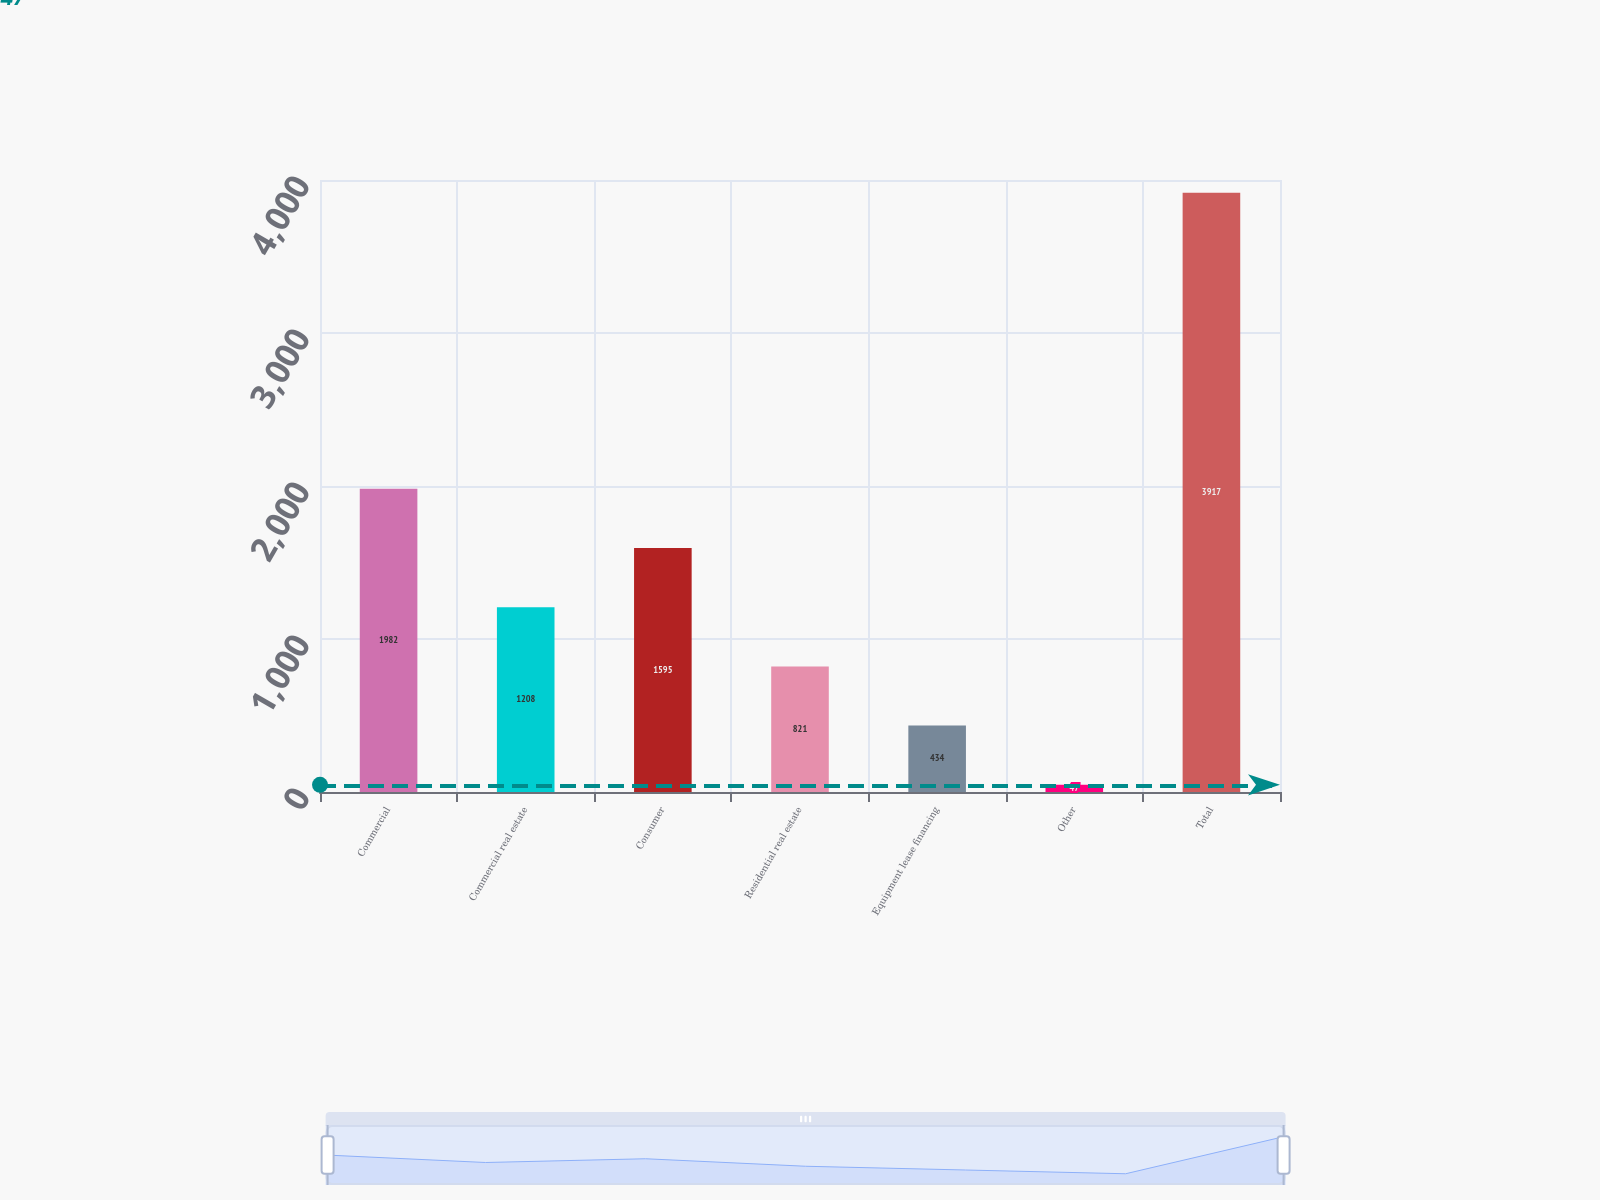Convert chart to OTSL. <chart><loc_0><loc_0><loc_500><loc_500><bar_chart><fcel>Commercial<fcel>Commercial real estate<fcel>Consumer<fcel>Residential real estate<fcel>Equipment lease financing<fcel>Other<fcel>Total<nl><fcel>1982<fcel>1208<fcel>1595<fcel>821<fcel>434<fcel>47<fcel>3917<nl></chart> 